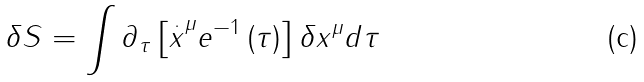<formula> <loc_0><loc_0><loc_500><loc_500>\delta S = \int \partial _ { \tau } \left [ \overset { . } { x } ^ { \mu } e ^ { - 1 } \left ( \tau \right ) \right ] \delta x ^ { \mu } d \tau</formula> 